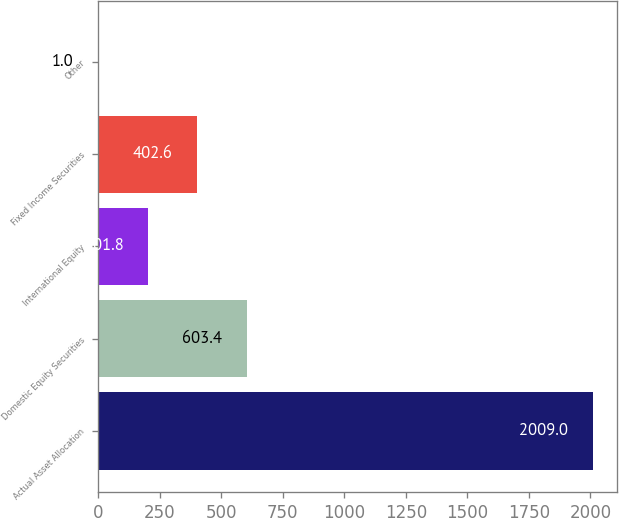Convert chart to OTSL. <chart><loc_0><loc_0><loc_500><loc_500><bar_chart><fcel>Actual Asset Allocation<fcel>Domestic Equity Securities<fcel>International Equity<fcel>Fixed Income Securities<fcel>Other<nl><fcel>2009<fcel>603.4<fcel>201.8<fcel>402.6<fcel>1<nl></chart> 